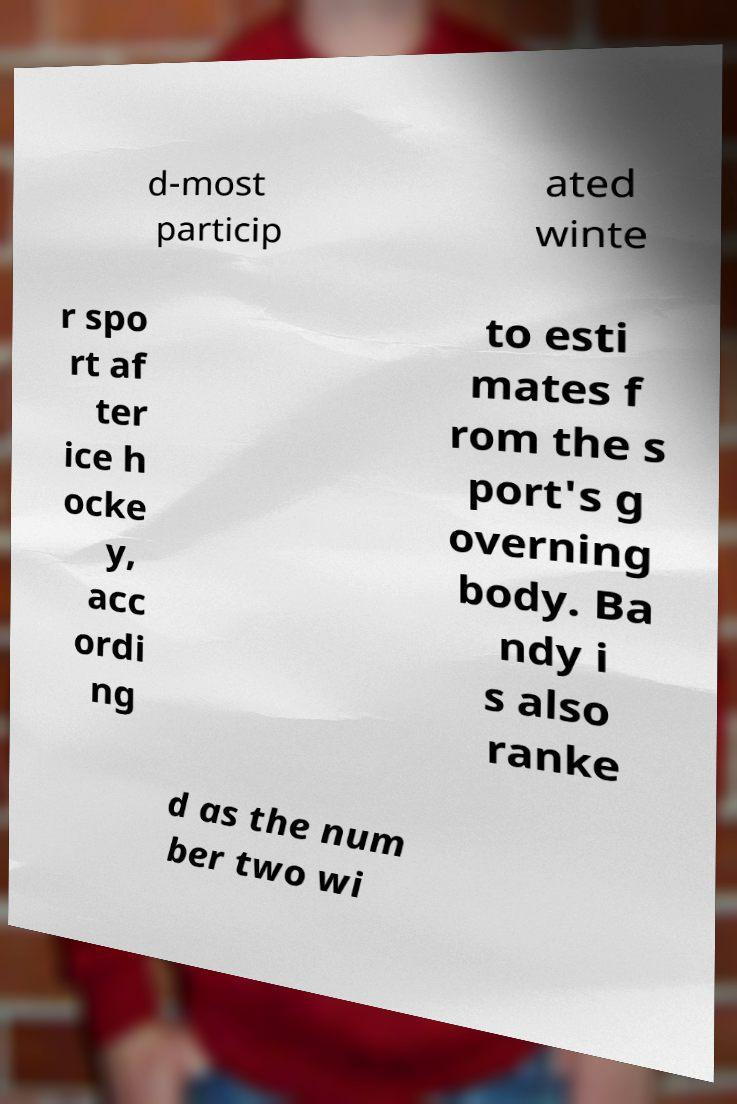Could you assist in decoding the text presented in this image and type it out clearly? d-most particip ated winte r spo rt af ter ice h ocke y, acc ordi ng to esti mates f rom the s port's g overning body. Ba ndy i s also ranke d as the num ber two wi 